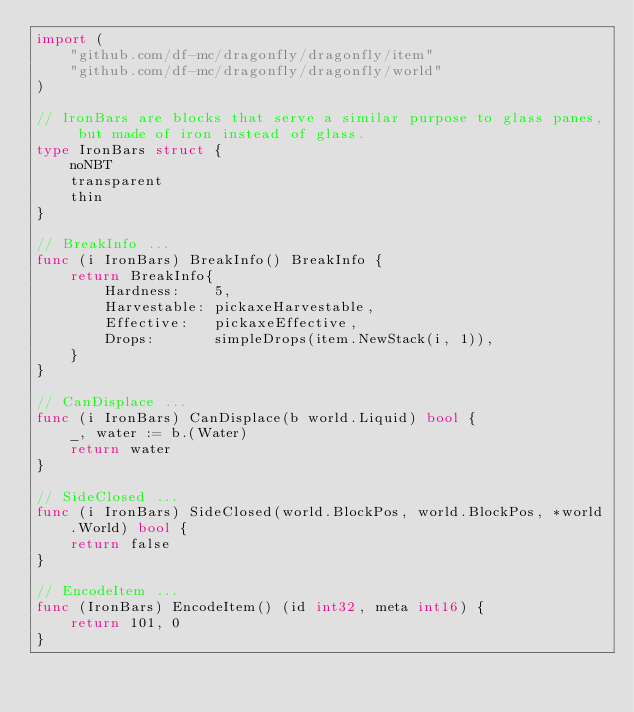Convert code to text. <code><loc_0><loc_0><loc_500><loc_500><_Go_>import (
	"github.com/df-mc/dragonfly/dragonfly/item"
	"github.com/df-mc/dragonfly/dragonfly/world"
)

// IronBars are blocks that serve a similar purpose to glass panes, but made of iron instead of glass.
type IronBars struct {
	noNBT
	transparent
	thin
}

// BreakInfo ...
func (i IronBars) BreakInfo() BreakInfo {
	return BreakInfo{
		Hardness:    5,
		Harvestable: pickaxeHarvestable,
		Effective:   pickaxeEffective,
		Drops:       simpleDrops(item.NewStack(i, 1)),
	}
}

// CanDisplace ...
func (i IronBars) CanDisplace(b world.Liquid) bool {
	_, water := b.(Water)
	return water
}

// SideClosed ...
func (i IronBars) SideClosed(world.BlockPos, world.BlockPos, *world.World) bool {
	return false
}

// EncodeItem ...
func (IronBars) EncodeItem() (id int32, meta int16) {
	return 101, 0
}
</code> 